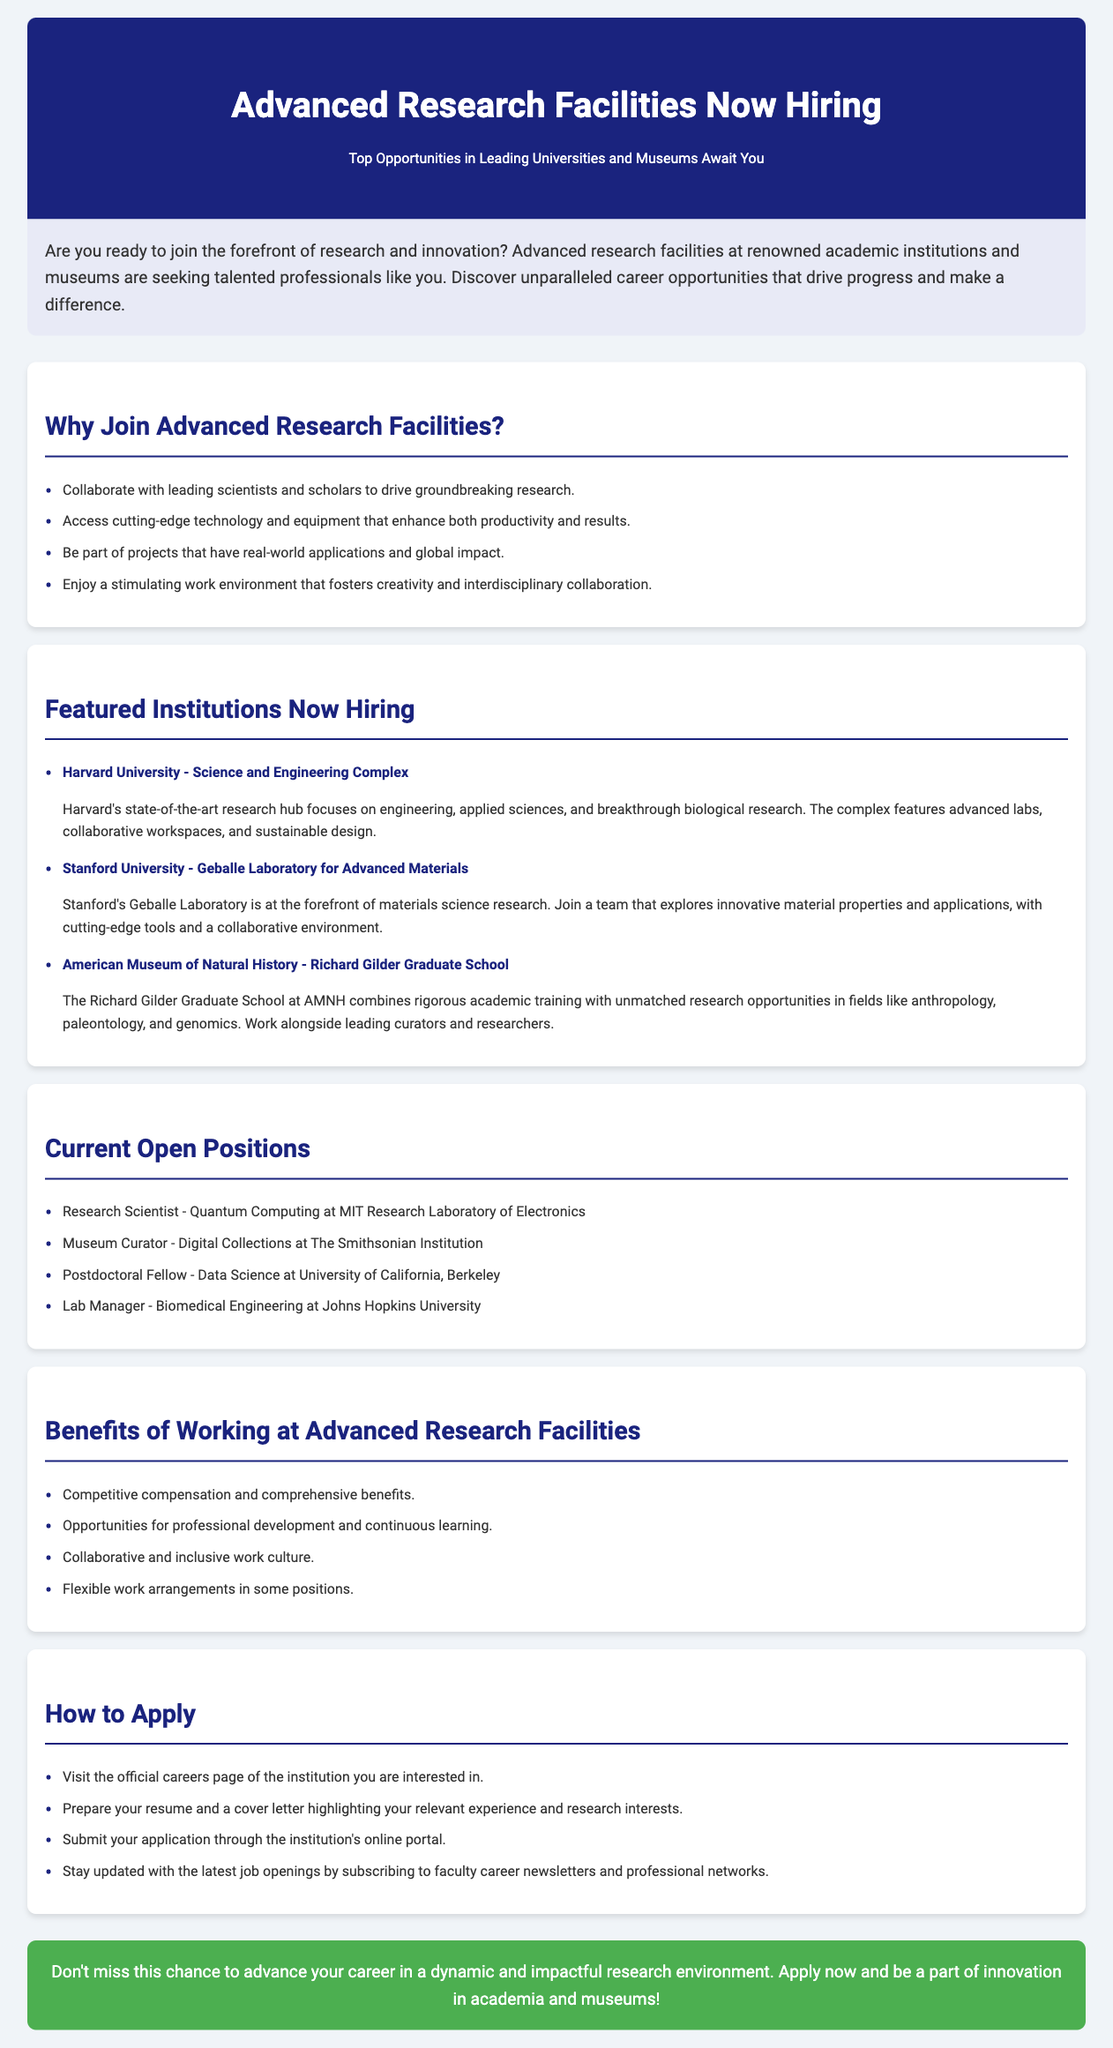What are the top opportunities? The document specifies that top opportunities are available in leading universities and museums.
Answer: Leading universities and museums What is the focus of Harvard's Science and Engineering Complex? It focuses on engineering, applied sciences, and breakthrough biological research.
Answer: Engineering, applied sciences, and breakthrough biological research Which position is currently available at MIT? The document lists the Research Scientist as a current open position at MIT Research Laboratory of Electronics.
Answer: Research Scientist What is one benefit of working at Advanced Research Facilities? The document mentions competitive compensation as one of the benefits.
Answer: Competitive compensation How can candidates stay updated with job openings? Candidates can stay updated by subscribing to faculty career newsletters and professional networks.
Answer: Subscribing to faculty career newsletters and professional networks What is emphasized in the work environment? The document emphasizes a stimulating work environment that fosters creativity and interdisciplinary collaboration.
Answer: Stimulating work environment Which graduate school is mentioned in conjunction with the American Museum of Natural History? The Richard Gilder Graduate School is mentioned in the document.
Answer: Richard Gilder Graduate School What type of job involves digital collections? The document specifies that the position titled Museum Curator is related to digital collections.
Answer: Museum Curator 